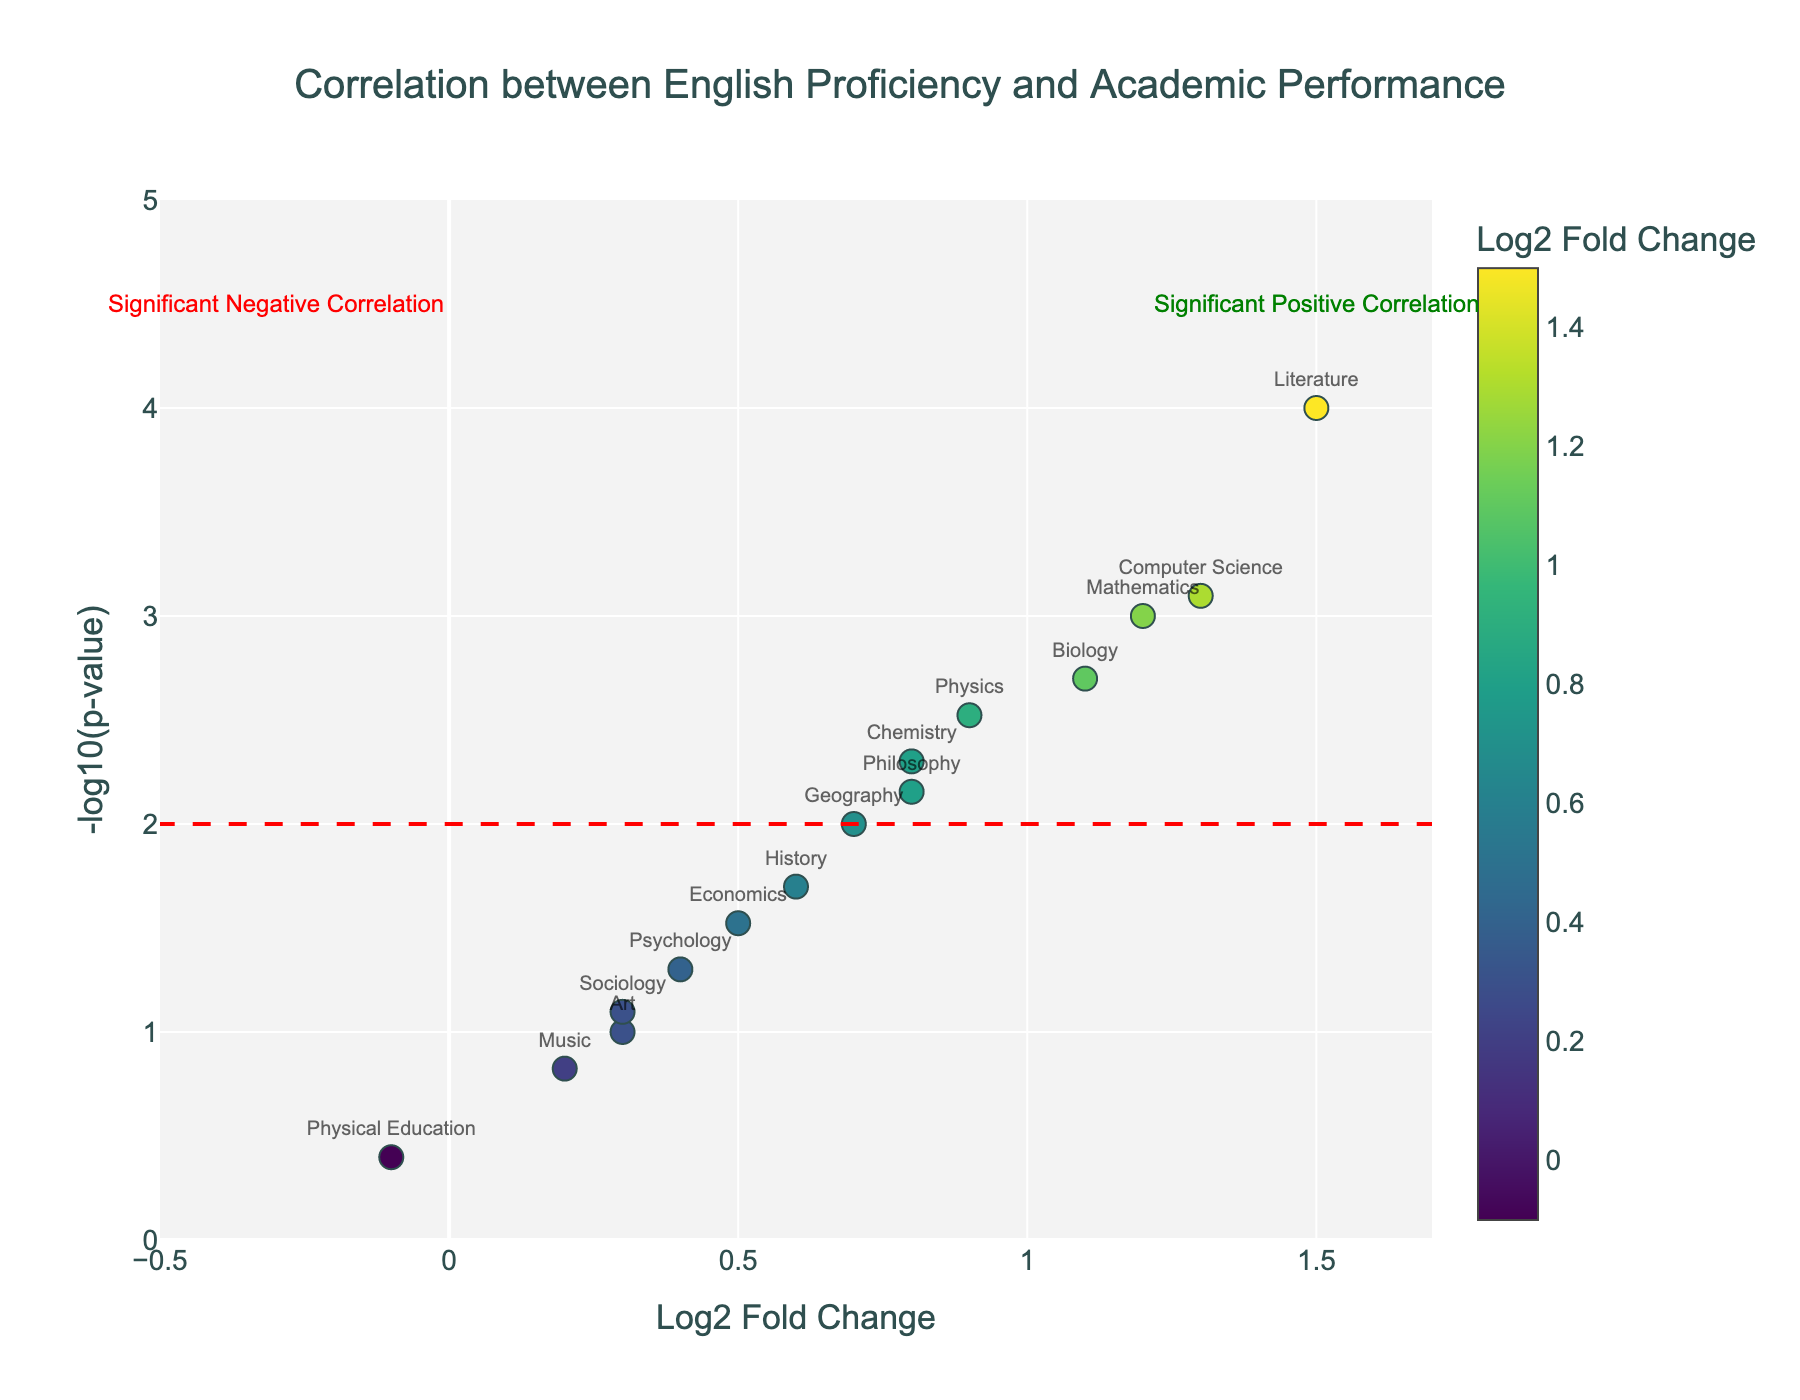What is the title of the figure? The title is usually placed at the top of the figure and provides a brief description of what the figure is about. In this case, the title reads "Correlation between English Proficiency and Academic Performance."
Answer: Correlation between English Proficiency and Academic Performance What do the x-axis and y-axis represent? The x-axis represents the "Log2 Fold Change," which indicates the change in academic performance with varying proficiency in English. The y-axis represents "-log10(p-value)", which is a statistical measure indicating the significance of the correlation.
Answer: Log2 Fold Change and -log10(p-value) Which subjects have a significant positive correlation with English proficiency? Subjects above the significance line (y=2) with positive Log2 Fold Change values show a significant positive correlation. These can be seen plotted higher than the line and on the right side of the y-axis.
Answer: Mathematics, Physics, Chemistry, Biology, Literature, Computer Science Which subject shows the most significant correlation with English proficiency? The subject at the highest point on the y-axis indicates the most significant correlation, which in this case is labeled by the corresponding marker with the greatest "-log10(p-value)."
Answer: Literature How many subjects show no significant correlation with English proficiency? Subjects below the significance line (y=2) show no significant correlation. By counting these markers, we determine how many fall below this line.
Answer: 7 Which subject has the least significant positive correlation with English proficiency? The least significant correlations are determined by observing the points just above the significance line (y=2) with positive Log2 Fold Change values.
Answer: Geography What is the Log2 Fold Change value for Physical Education? The Log2 Fold Change for Physical Education is the x-coordinate of the point labeled "Physical Education."
Answer: -0.1 Which subjects have a p-value less than 0.01? Subjects with a p-value less than 0.01 have coordinates such that the y-coordinate (−log10(p-value)) is greater than 2. By spotting these points, we can identify the subjects.
Answer: Mathematics, Physics, Chemistry, Biology, Literature, Computer Science, Philosophy Which subject is near the origin of the plot? The subject closest to the intersection of the x-axis and y-axis (0, 0) is identified by observing the points near this point.
Answer: Physical Education Which subjects have negative Log2 Fold Change values? Subjects with markers left of the y-axis have negative Log2 Fold Change values, indicating a decrease in academic performance with higher English proficiency.
Answer: Physical Education 